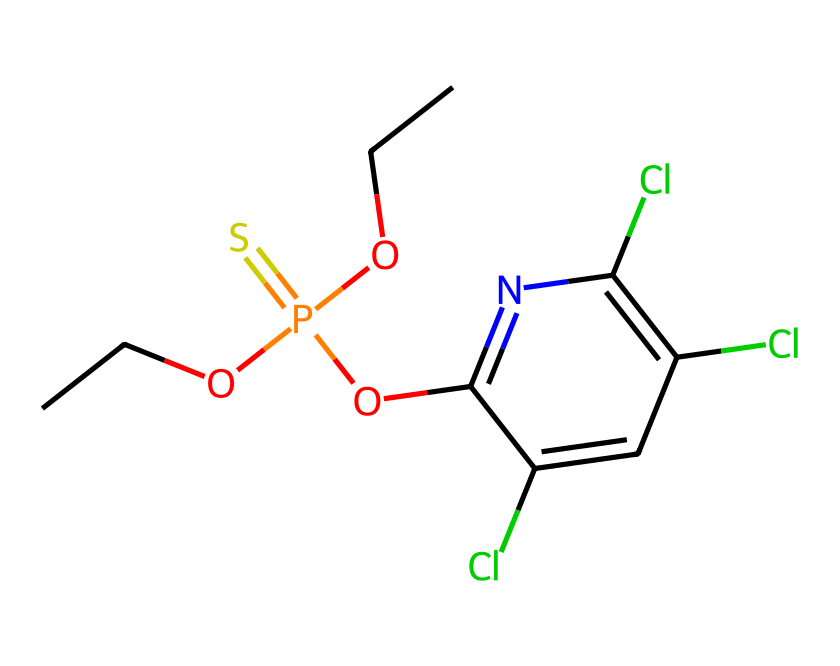What type of chemical structure is represented by this SMILES? The provided SMILES corresponds to an organophosphate pesticide, as indicated by the presence of phosphorus (P) and sulfur (S) along with organic groups.
Answer: organophosphate pesticide How many chlorine atoms are in the chemical structure? By analyzing the SMILES, there are three 'Cl' notations, indicating the presence of three chlorine atoms in the structure.
Answer: three What is the total number of carbon atoms in the chemical formula? Counting the 'C' notations in the SMILES, there are six carbon atoms present in the structure.
Answer: six Which functional group is present in this pesticide? The presence of the 'PO' notation indicates a phosphate group, which is characteristic of organophosphate pesticides.
Answer: phosphate group What type of binding is primarily responsible for the toxicity of organophosphate pesticides? The bonding type involves the inhibition of acetylcholinesterase, primarily due to the reaction of the pesticide with the active site of the enzyme, most often via covalent bonding.
Answer: covalent bonding 